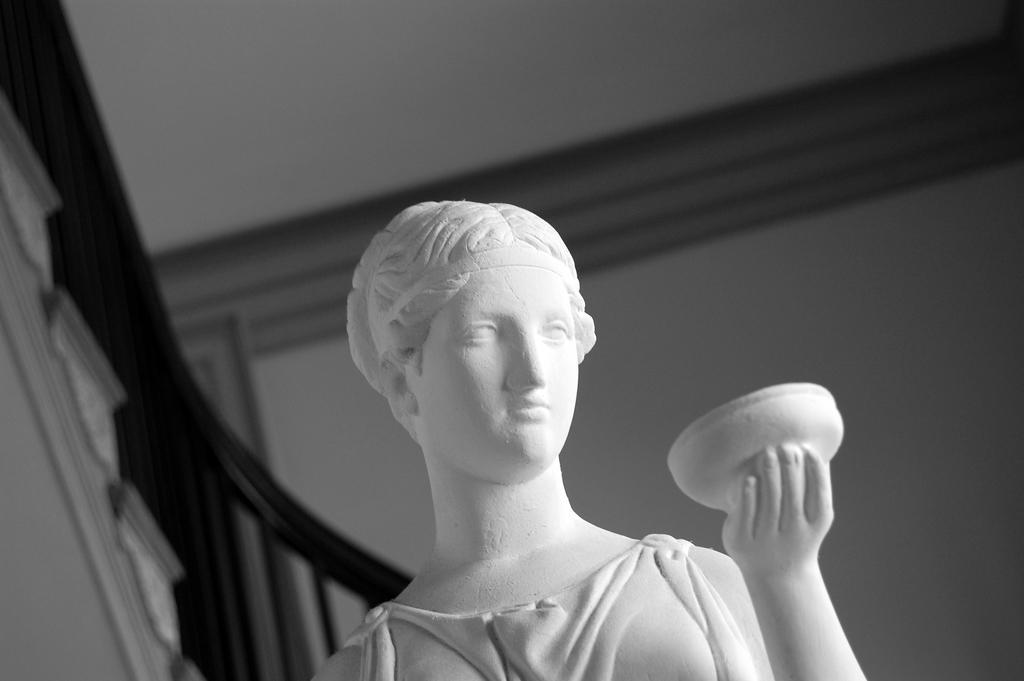How would you summarize this image in a sentence or two? This is a black and white image Here I can see a statue of a person. On the left side I can see the stairs and railing. In the background there is a wall. 